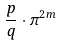Convert formula to latex. <formula><loc_0><loc_0><loc_500><loc_500>\frac { p } { q } \cdot \pi ^ { 2 m }</formula> 